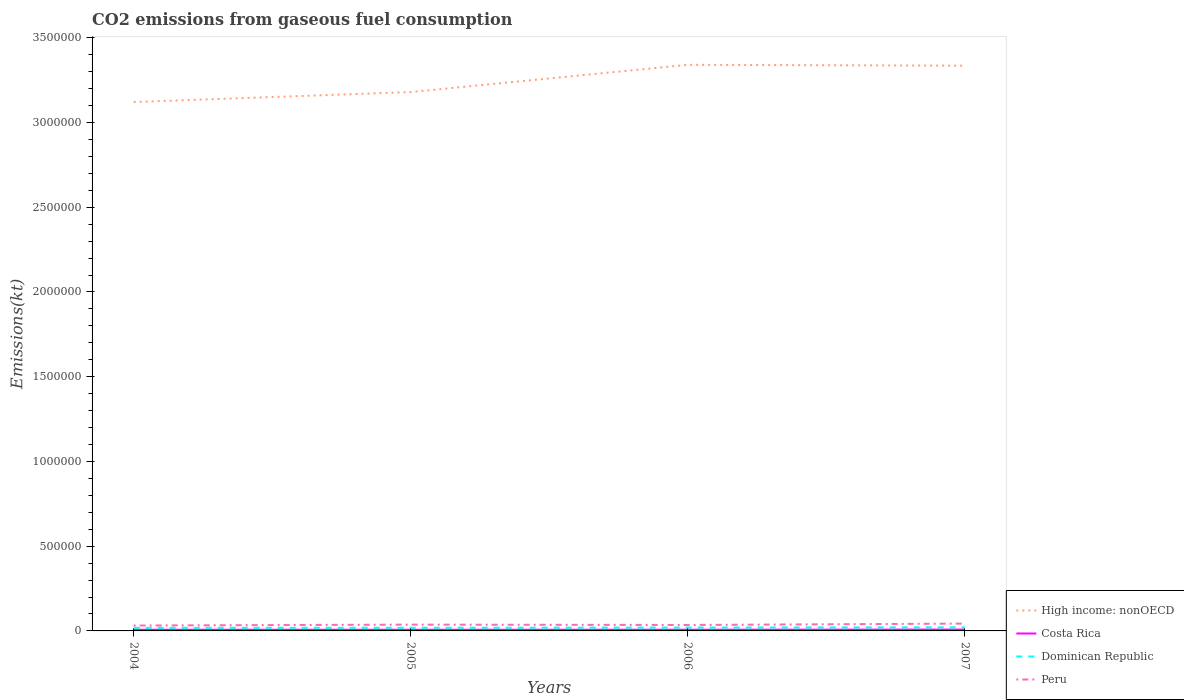How many different coloured lines are there?
Offer a terse response. 4. Is the number of lines equal to the number of legend labels?
Your answer should be compact. Yes. Across all years, what is the maximum amount of CO2 emitted in Peru?
Offer a very short reply. 3.19e+04. In which year was the amount of CO2 emitted in Dominican Republic maximum?
Your response must be concise. 2004. What is the total amount of CO2 emitted in Dominican Republic in the graph?
Provide a succinct answer. -2992.27. What is the difference between the highest and the second highest amount of CO2 emitted in Peru?
Make the answer very short. 1.13e+04. What is the difference between the highest and the lowest amount of CO2 emitted in Peru?
Offer a terse response. 2. Is the amount of CO2 emitted in Dominican Republic strictly greater than the amount of CO2 emitted in High income: nonOECD over the years?
Offer a very short reply. Yes. How many lines are there?
Provide a short and direct response. 4. Are the values on the major ticks of Y-axis written in scientific E-notation?
Ensure brevity in your answer.  No. Does the graph contain any zero values?
Keep it short and to the point. No. Where does the legend appear in the graph?
Provide a succinct answer. Bottom right. How many legend labels are there?
Give a very brief answer. 4. What is the title of the graph?
Keep it short and to the point. CO2 emissions from gaseous fuel consumption. What is the label or title of the X-axis?
Make the answer very short. Years. What is the label or title of the Y-axis?
Offer a very short reply. Emissions(kt). What is the Emissions(kt) in High income: nonOECD in 2004?
Your answer should be very brief. 3.12e+06. What is the Emissions(kt) in Costa Rica in 2004?
Your response must be concise. 6930.63. What is the Emissions(kt) in Dominican Republic in 2004?
Provide a succinct answer. 1.83e+04. What is the Emissions(kt) of Peru in 2004?
Provide a short and direct response. 3.19e+04. What is the Emissions(kt) in High income: nonOECD in 2005?
Give a very brief answer. 3.18e+06. What is the Emissions(kt) of Costa Rica in 2005?
Provide a short and direct response. 6868.29. What is the Emissions(kt) in Dominican Republic in 2005?
Give a very brief answer. 1.86e+04. What is the Emissions(kt) of Peru in 2005?
Your answer should be compact. 3.71e+04. What is the Emissions(kt) of High income: nonOECD in 2006?
Your answer should be very brief. 3.34e+06. What is the Emissions(kt) of Costa Rica in 2006?
Your answer should be compact. 7099.31. What is the Emissions(kt) in Dominican Republic in 2006?
Provide a short and direct response. 1.97e+04. What is the Emissions(kt) of Peru in 2006?
Offer a very short reply. 3.51e+04. What is the Emissions(kt) of High income: nonOECD in 2007?
Offer a very short reply. 3.34e+06. What is the Emissions(kt) in Costa Rica in 2007?
Keep it short and to the point. 8122.4. What is the Emissions(kt) in Dominican Republic in 2007?
Provide a short and direct response. 2.13e+04. What is the Emissions(kt) of Peru in 2007?
Provide a short and direct response. 4.32e+04. Across all years, what is the maximum Emissions(kt) in High income: nonOECD?
Offer a terse response. 3.34e+06. Across all years, what is the maximum Emissions(kt) in Costa Rica?
Provide a short and direct response. 8122.4. Across all years, what is the maximum Emissions(kt) in Dominican Republic?
Offer a terse response. 2.13e+04. Across all years, what is the maximum Emissions(kt) of Peru?
Your response must be concise. 4.32e+04. Across all years, what is the minimum Emissions(kt) of High income: nonOECD?
Ensure brevity in your answer.  3.12e+06. Across all years, what is the minimum Emissions(kt) in Costa Rica?
Make the answer very short. 6868.29. Across all years, what is the minimum Emissions(kt) in Dominican Republic?
Offer a very short reply. 1.83e+04. Across all years, what is the minimum Emissions(kt) in Peru?
Offer a terse response. 3.19e+04. What is the total Emissions(kt) in High income: nonOECD in the graph?
Make the answer very short. 1.30e+07. What is the total Emissions(kt) of Costa Rica in the graph?
Your answer should be very brief. 2.90e+04. What is the total Emissions(kt) in Dominican Republic in the graph?
Offer a terse response. 7.80e+04. What is the total Emissions(kt) in Peru in the graph?
Your answer should be very brief. 1.47e+05. What is the difference between the Emissions(kt) in High income: nonOECD in 2004 and that in 2005?
Your answer should be very brief. -5.89e+04. What is the difference between the Emissions(kt) in Costa Rica in 2004 and that in 2005?
Keep it short and to the point. 62.34. What is the difference between the Emissions(kt) in Dominican Republic in 2004 and that in 2005?
Provide a short and direct response. -330.03. What is the difference between the Emissions(kt) of Peru in 2004 and that in 2005?
Offer a terse response. -5240.14. What is the difference between the Emissions(kt) of High income: nonOECD in 2004 and that in 2006?
Give a very brief answer. -2.20e+05. What is the difference between the Emissions(kt) in Costa Rica in 2004 and that in 2006?
Provide a succinct answer. -168.68. What is the difference between the Emissions(kt) in Dominican Republic in 2004 and that in 2006?
Provide a succinct answer. -1400.79. What is the difference between the Emissions(kt) in Peru in 2004 and that in 2006?
Offer a very short reply. -3168.29. What is the difference between the Emissions(kt) in High income: nonOECD in 2004 and that in 2007?
Give a very brief answer. -2.15e+05. What is the difference between the Emissions(kt) of Costa Rica in 2004 and that in 2007?
Offer a very short reply. -1191.78. What is the difference between the Emissions(kt) in Dominican Republic in 2004 and that in 2007?
Offer a very short reply. -2992.27. What is the difference between the Emissions(kt) of Peru in 2004 and that in 2007?
Your answer should be compact. -1.13e+04. What is the difference between the Emissions(kt) of High income: nonOECD in 2005 and that in 2006?
Keep it short and to the point. -1.61e+05. What is the difference between the Emissions(kt) in Costa Rica in 2005 and that in 2006?
Your answer should be very brief. -231.02. What is the difference between the Emissions(kt) of Dominican Republic in 2005 and that in 2006?
Make the answer very short. -1070.76. What is the difference between the Emissions(kt) in Peru in 2005 and that in 2006?
Provide a short and direct response. 2071.86. What is the difference between the Emissions(kt) in High income: nonOECD in 2005 and that in 2007?
Make the answer very short. -1.56e+05. What is the difference between the Emissions(kt) in Costa Rica in 2005 and that in 2007?
Give a very brief answer. -1254.11. What is the difference between the Emissions(kt) in Dominican Republic in 2005 and that in 2007?
Give a very brief answer. -2662.24. What is the difference between the Emissions(kt) of Peru in 2005 and that in 2007?
Offer a very short reply. -6072.55. What is the difference between the Emissions(kt) of High income: nonOECD in 2006 and that in 2007?
Keep it short and to the point. 4914.35. What is the difference between the Emissions(kt) of Costa Rica in 2006 and that in 2007?
Give a very brief answer. -1023.09. What is the difference between the Emissions(kt) of Dominican Republic in 2006 and that in 2007?
Offer a terse response. -1591.48. What is the difference between the Emissions(kt) in Peru in 2006 and that in 2007?
Offer a terse response. -8144.41. What is the difference between the Emissions(kt) in High income: nonOECD in 2004 and the Emissions(kt) in Costa Rica in 2005?
Provide a short and direct response. 3.11e+06. What is the difference between the Emissions(kt) of High income: nonOECD in 2004 and the Emissions(kt) of Dominican Republic in 2005?
Offer a very short reply. 3.10e+06. What is the difference between the Emissions(kt) in High income: nonOECD in 2004 and the Emissions(kt) in Peru in 2005?
Provide a succinct answer. 3.08e+06. What is the difference between the Emissions(kt) of Costa Rica in 2004 and the Emissions(kt) of Dominican Republic in 2005?
Your answer should be very brief. -1.17e+04. What is the difference between the Emissions(kt) in Costa Rica in 2004 and the Emissions(kt) in Peru in 2005?
Offer a very short reply. -3.02e+04. What is the difference between the Emissions(kt) of Dominican Republic in 2004 and the Emissions(kt) of Peru in 2005?
Give a very brief answer. -1.88e+04. What is the difference between the Emissions(kt) of High income: nonOECD in 2004 and the Emissions(kt) of Costa Rica in 2006?
Ensure brevity in your answer.  3.11e+06. What is the difference between the Emissions(kt) of High income: nonOECD in 2004 and the Emissions(kt) of Dominican Republic in 2006?
Ensure brevity in your answer.  3.10e+06. What is the difference between the Emissions(kt) in High income: nonOECD in 2004 and the Emissions(kt) in Peru in 2006?
Your answer should be very brief. 3.09e+06. What is the difference between the Emissions(kt) of Costa Rica in 2004 and the Emissions(kt) of Dominican Republic in 2006?
Your response must be concise. -1.28e+04. What is the difference between the Emissions(kt) of Costa Rica in 2004 and the Emissions(kt) of Peru in 2006?
Your response must be concise. -2.81e+04. What is the difference between the Emissions(kt) in Dominican Republic in 2004 and the Emissions(kt) in Peru in 2006?
Keep it short and to the point. -1.68e+04. What is the difference between the Emissions(kt) in High income: nonOECD in 2004 and the Emissions(kt) in Costa Rica in 2007?
Offer a terse response. 3.11e+06. What is the difference between the Emissions(kt) in High income: nonOECD in 2004 and the Emissions(kt) in Dominican Republic in 2007?
Give a very brief answer. 3.10e+06. What is the difference between the Emissions(kt) of High income: nonOECD in 2004 and the Emissions(kt) of Peru in 2007?
Give a very brief answer. 3.08e+06. What is the difference between the Emissions(kt) of Costa Rica in 2004 and the Emissions(kt) of Dominican Republic in 2007?
Keep it short and to the point. -1.44e+04. What is the difference between the Emissions(kt) of Costa Rica in 2004 and the Emissions(kt) of Peru in 2007?
Your answer should be compact. -3.63e+04. What is the difference between the Emissions(kt) in Dominican Republic in 2004 and the Emissions(kt) in Peru in 2007?
Your answer should be compact. -2.49e+04. What is the difference between the Emissions(kt) in High income: nonOECD in 2005 and the Emissions(kt) in Costa Rica in 2006?
Offer a terse response. 3.17e+06. What is the difference between the Emissions(kt) in High income: nonOECD in 2005 and the Emissions(kt) in Dominican Republic in 2006?
Offer a very short reply. 3.16e+06. What is the difference between the Emissions(kt) in High income: nonOECD in 2005 and the Emissions(kt) in Peru in 2006?
Provide a short and direct response. 3.14e+06. What is the difference between the Emissions(kt) in Costa Rica in 2005 and the Emissions(kt) in Dominican Republic in 2006?
Provide a short and direct response. -1.28e+04. What is the difference between the Emissions(kt) in Costa Rica in 2005 and the Emissions(kt) in Peru in 2006?
Offer a very short reply. -2.82e+04. What is the difference between the Emissions(kt) in Dominican Republic in 2005 and the Emissions(kt) in Peru in 2006?
Your answer should be compact. -1.64e+04. What is the difference between the Emissions(kt) of High income: nonOECD in 2005 and the Emissions(kt) of Costa Rica in 2007?
Your answer should be compact. 3.17e+06. What is the difference between the Emissions(kt) in High income: nonOECD in 2005 and the Emissions(kt) in Dominican Republic in 2007?
Keep it short and to the point. 3.16e+06. What is the difference between the Emissions(kt) of High income: nonOECD in 2005 and the Emissions(kt) of Peru in 2007?
Your response must be concise. 3.14e+06. What is the difference between the Emissions(kt) in Costa Rica in 2005 and the Emissions(kt) in Dominican Republic in 2007?
Provide a succinct answer. -1.44e+04. What is the difference between the Emissions(kt) in Costa Rica in 2005 and the Emissions(kt) in Peru in 2007?
Keep it short and to the point. -3.63e+04. What is the difference between the Emissions(kt) in Dominican Republic in 2005 and the Emissions(kt) in Peru in 2007?
Provide a short and direct response. -2.46e+04. What is the difference between the Emissions(kt) in High income: nonOECD in 2006 and the Emissions(kt) in Costa Rica in 2007?
Provide a succinct answer. 3.33e+06. What is the difference between the Emissions(kt) in High income: nonOECD in 2006 and the Emissions(kt) in Dominican Republic in 2007?
Offer a terse response. 3.32e+06. What is the difference between the Emissions(kt) of High income: nonOECD in 2006 and the Emissions(kt) of Peru in 2007?
Your response must be concise. 3.30e+06. What is the difference between the Emissions(kt) in Costa Rica in 2006 and the Emissions(kt) in Dominican Republic in 2007?
Provide a succinct answer. -1.42e+04. What is the difference between the Emissions(kt) of Costa Rica in 2006 and the Emissions(kt) of Peru in 2007?
Offer a terse response. -3.61e+04. What is the difference between the Emissions(kt) in Dominican Republic in 2006 and the Emissions(kt) in Peru in 2007?
Provide a short and direct response. -2.35e+04. What is the average Emissions(kt) in High income: nonOECD per year?
Offer a very short reply. 3.24e+06. What is the average Emissions(kt) of Costa Rica per year?
Your answer should be compact. 7255.16. What is the average Emissions(kt) in Dominican Republic per year?
Make the answer very short. 1.95e+04. What is the average Emissions(kt) of Peru per year?
Keep it short and to the point. 3.68e+04. In the year 2004, what is the difference between the Emissions(kt) of High income: nonOECD and Emissions(kt) of Costa Rica?
Your answer should be compact. 3.11e+06. In the year 2004, what is the difference between the Emissions(kt) in High income: nonOECD and Emissions(kt) in Dominican Republic?
Your answer should be compact. 3.10e+06. In the year 2004, what is the difference between the Emissions(kt) of High income: nonOECD and Emissions(kt) of Peru?
Offer a very short reply. 3.09e+06. In the year 2004, what is the difference between the Emissions(kt) in Costa Rica and Emissions(kt) in Dominican Republic?
Give a very brief answer. -1.14e+04. In the year 2004, what is the difference between the Emissions(kt) in Costa Rica and Emissions(kt) in Peru?
Provide a succinct answer. -2.50e+04. In the year 2004, what is the difference between the Emissions(kt) in Dominican Republic and Emissions(kt) in Peru?
Your response must be concise. -1.36e+04. In the year 2005, what is the difference between the Emissions(kt) of High income: nonOECD and Emissions(kt) of Costa Rica?
Your answer should be compact. 3.17e+06. In the year 2005, what is the difference between the Emissions(kt) in High income: nonOECD and Emissions(kt) in Dominican Republic?
Your answer should be compact. 3.16e+06. In the year 2005, what is the difference between the Emissions(kt) of High income: nonOECD and Emissions(kt) of Peru?
Ensure brevity in your answer.  3.14e+06. In the year 2005, what is the difference between the Emissions(kt) in Costa Rica and Emissions(kt) in Dominican Republic?
Your response must be concise. -1.18e+04. In the year 2005, what is the difference between the Emissions(kt) in Costa Rica and Emissions(kt) in Peru?
Your response must be concise. -3.03e+04. In the year 2005, what is the difference between the Emissions(kt) in Dominican Republic and Emissions(kt) in Peru?
Offer a very short reply. -1.85e+04. In the year 2006, what is the difference between the Emissions(kt) of High income: nonOECD and Emissions(kt) of Costa Rica?
Your answer should be compact. 3.33e+06. In the year 2006, what is the difference between the Emissions(kt) in High income: nonOECD and Emissions(kt) in Dominican Republic?
Provide a succinct answer. 3.32e+06. In the year 2006, what is the difference between the Emissions(kt) of High income: nonOECD and Emissions(kt) of Peru?
Your answer should be very brief. 3.31e+06. In the year 2006, what is the difference between the Emissions(kt) of Costa Rica and Emissions(kt) of Dominican Republic?
Provide a short and direct response. -1.26e+04. In the year 2006, what is the difference between the Emissions(kt) in Costa Rica and Emissions(kt) in Peru?
Offer a terse response. -2.80e+04. In the year 2006, what is the difference between the Emissions(kt) of Dominican Republic and Emissions(kt) of Peru?
Give a very brief answer. -1.54e+04. In the year 2007, what is the difference between the Emissions(kt) of High income: nonOECD and Emissions(kt) of Costa Rica?
Your answer should be compact. 3.33e+06. In the year 2007, what is the difference between the Emissions(kt) of High income: nonOECD and Emissions(kt) of Dominican Republic?
Your answer should be compact. 3.31e+06. In the year 2007, what is the difference between the Emissions(kt) of High income: nonOECD and Emissions(kt) of Peru?
Provide a succinct answer. 3.29e+06. In the year 2007, what is the difference between the Emissions(kt) in Costa Rica and Emissions(kt) in Dominican Republic?
Offer a terse response. -1.32e+04. In the year 2007, what is the difference between the Emissions(kt) of Costa Rica and Emissions(kt) of Peru?
Keep it short and to the point. -3.51e+04. In the year 2007, what is the difference between the Emissions(kt) of Dominican Republic and Emissions(kt) of Peru?
Give a very brief answer. -2.19e+04. What is the ratio of the Emissions(kt) of High income: nonOECD in 2004 to that in 2005?
Ensure brevity in your answer.  0.98. What is the ratio of the Emissions(kt) of Costa Rica in 2004 to that in 2005?
Your answer should be compact. 1.01. What is the ratio of the Emissions(kt) of Dominican Republic in 2004 to that in 2005?
Your answer should be compact. 0.98. What is the ratio of the Emissions(kt) in Peru in 2004 to that in 2005?
Give a very brief answer. 0.86. What is the ratio of the Emissions(kt) of High income: nonOECD in 2004 to that in 2006?
Offer a terse response. 0.93. What is the ratio of the Emissions(kt) of Costa Rica in 2004 to that in 2006?
Keep it short and to the point. 0.98. What is the ratio of the Emissions(kt) in Dominican Republic in 2004 to that in 2006?
Your answer should be very brief. 0.93. What is the ratio of the Emissions(kt) of Peru in 2004 to that in 2006?
Your answer should be very brief. 0.91. What is the ratio of the Emissions(kt) in High income: nonOECD in 2004 to that in 2007?
Your answer should be compact. 0.94. What is the ratio of the Emissions(kt) of Costa Rica in 2004 to that in 2007?
Give a very brief answer. 0.85. What is the ratio of the Emissions(kt) in Dominican Republic in 2004 to that in 2007?
Offer a very short reply. 0.86. What is the ratio of the Emissions(kt) of Peru in 2004 to that in 2007?
Provide a short and direct response. 0.74. What is the ratio of the Emissions(kt) of High income: nonOECD in 2005 to that in 2006?
Make the answer very short. 0.95. What is the ratio of the Emissions(kt) in Costa Rica in 2005 to that in 2006?
Offer a terse response. 0.97. What is the ratio of the Emissions(kt) of Dominican Republic in 2005 to that in 2006?
Provide a succinct answer. 0.95. What is the ratio of the Emissions(kt) of Peru in 2005 to that in 2006?
Ensure brevity in your answer.  1.06. What is the ratio of the Emissions(kt) of High income: nonOECD in 2005 to that in 2007?
Offer a terse response. 0.95. What is the ratio of the Emissions(kt) in Costa Rica in 2005 to that in 2007?
Your answer should be compact. 0.85. What is the ratio of the Emissions(kt) of Peru in 2005 to that in 2007?
Offer a terse response. 0.86. What is the ratio of the Emissions(kt) in Costa Rica in 2006 to that in 2007?
Offer a terse response. 0.87. What is the ratio of the Emissions(kt) of Dominican Republic in 2006 to that in 2007?
Make the answer very short. 0.93. What is the ratio of the Emissions(kt) of Peru in 2006 to that in 2007?
Give a very brief answer. 0.81. What is the difference between the highest and the second highest Emissions(kt) in High income: nonOECD?
Ensure brevity in your answer.  4914.35. What is the difference between the highest and the second highest Emissions(kt) of Costa Rica?
Provide a short and direct response. 1023.09. What is the difference between the highest and the second highest Emissions(kt) of Dominican Republic?
Make the answer very short. 1591.48. What is the difference between the highest and the second highest Emissions(kt) of Peru?
Provide a short and direct response. 6072.55. What is the difference between the highest and the lowest Emissions(kt) in High income: nonOECD?
Keep it short and to the point. 2.20e+05. What is the difference between the highest and the lowest Emissions(kt) of Costa Rica?
Offer a very short reply. 1254.11. What is the difference between the highest and the lowest Emissions(kt) of Dominican Republic?
Give a very brief answer. 2992.27. What is the difference between the highest and the lowest Emissions(kt) of Peru?
Provide a short and direct response. 1.13e+04. 